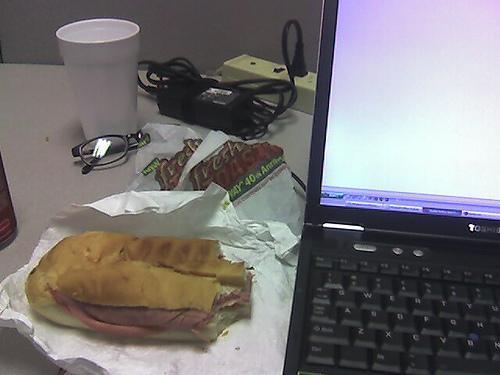How many laptops can be seen?
Give a very brief answer. 1. 